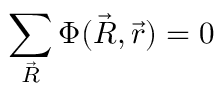Convert formula to latex. <formula><loc_0><loc_0><loc_500><loc_500>\sum _ { \vec { R } } \Phi ( \vec { R } , \vec { r } ) = 0</formula> 